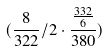<formula> <loc_0><loc_0><loc_500><loc_500>( \frac { 8 } { 3 2 2 } / 2 \cdot \frac { \frac { 3 3 2 } { 6 } } { 3 8 0 } )</formula> 